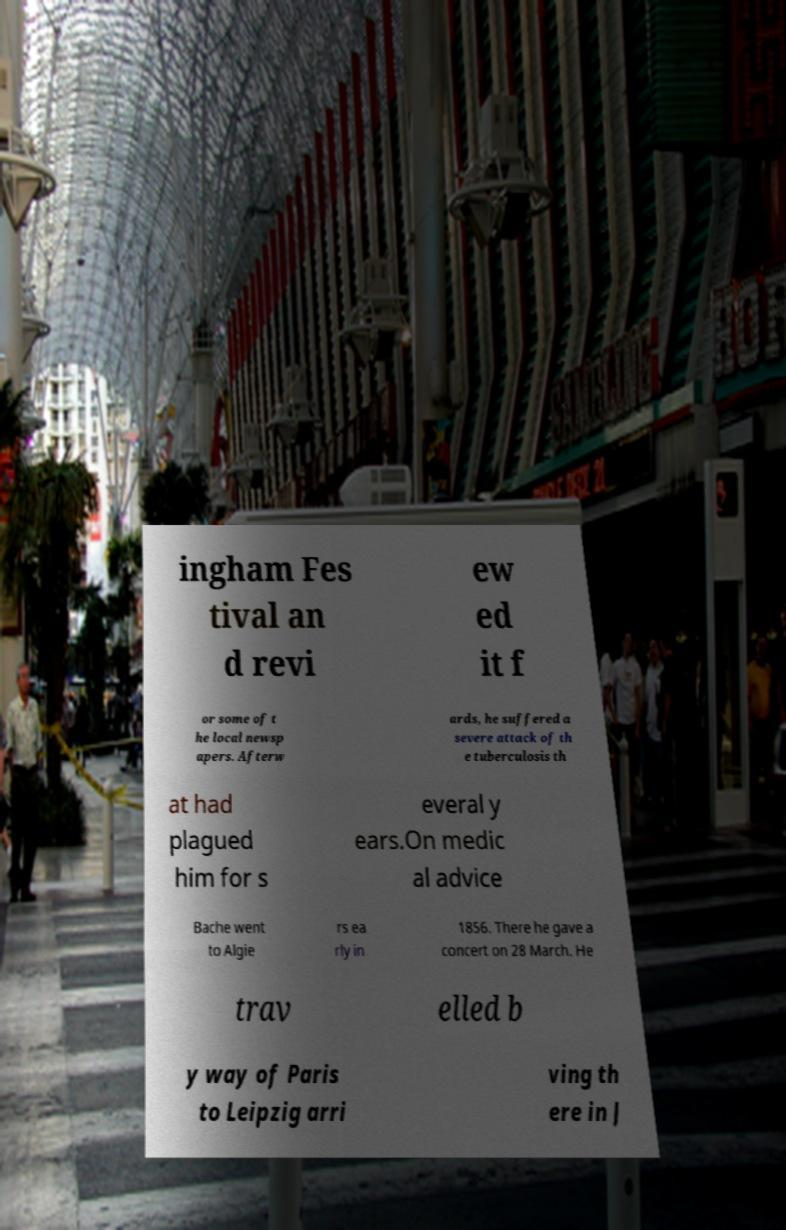Can you accurately transcribe the text from the provided image for me? ingham Fes tival an d revi ew ed it f or some of t he local newsp apers. Afterw ards, he suffered a severe attack of th e tuberculosis th at had plagued him for s everal y ears.On medic al advice Bache went to Algie rs ea rly in 1856. There he gave a concert on 28 March. He trav elled b y way of Paris to Leipzig arri ving th ere in J 